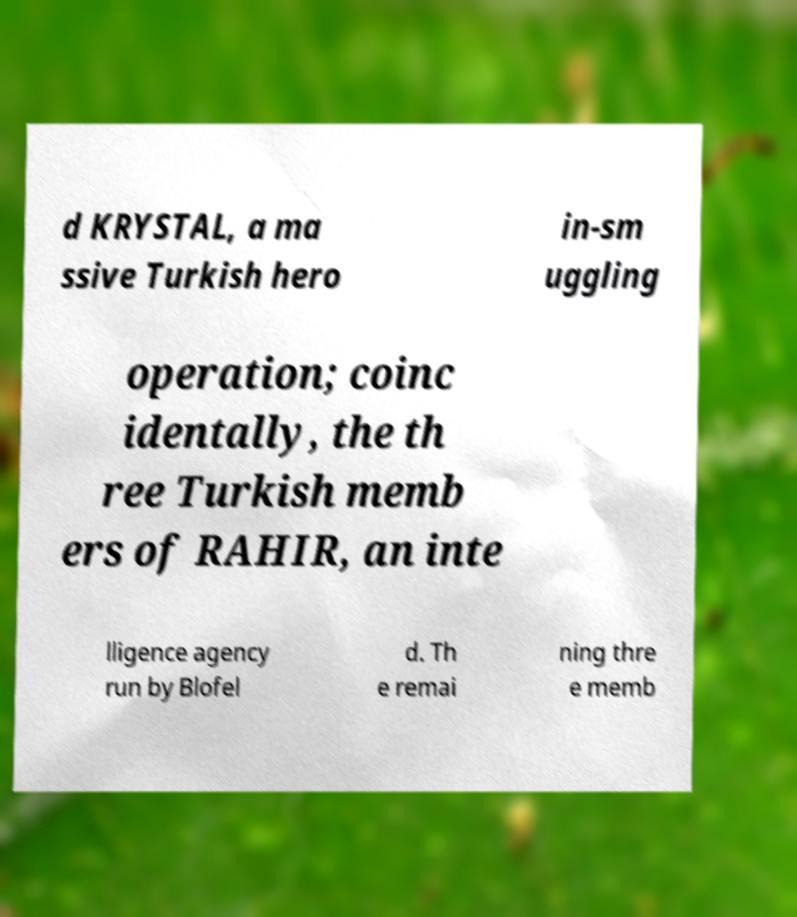Please read and relay the text visible in this image. What does it say? d KRYSTAL, a ma ssive Turkish hero in-sm uggling operation; coinc identally, the th ree Turkish memb ers of RAHIR, an inte lligence agency run by Blofel d. Th e remai ning thre e memb 